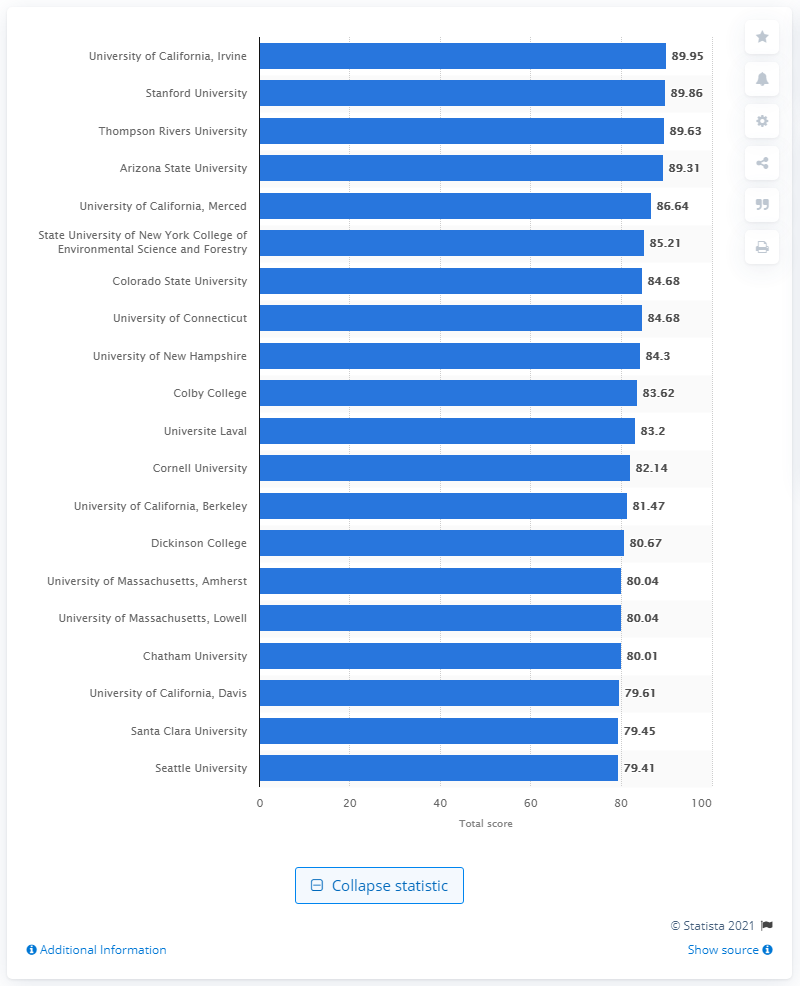Highlight a few significant elements in this photo. The University of California, Irvine was ranked as the greenest university in the United States for 2020, according to a ranking. 